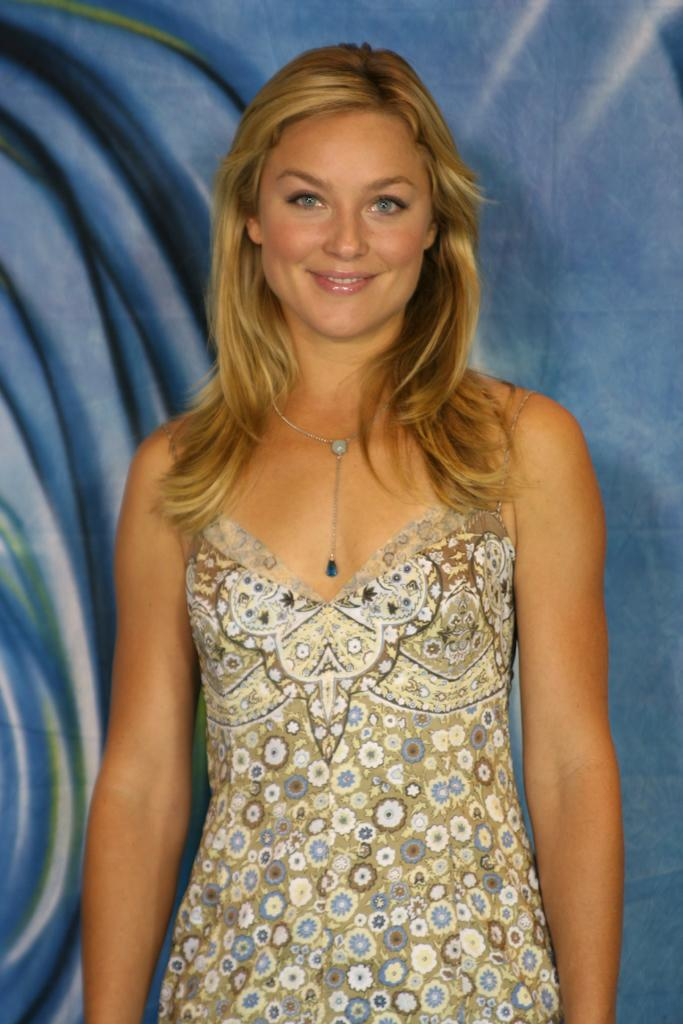Who is present in the image? There is a woman in the image. What is the woman doing in the image? The woman is standing in the image. What is the woman's facial expression in the image? The woman is smiling in the image. What accessory is the woman wearing in the image? The woman is wearing a chain around her neck in the image. What type of veil is covering the woman's face in the image? There is no veil covering the woman's face in the image; she is smiling and not wearing any facial covering. 